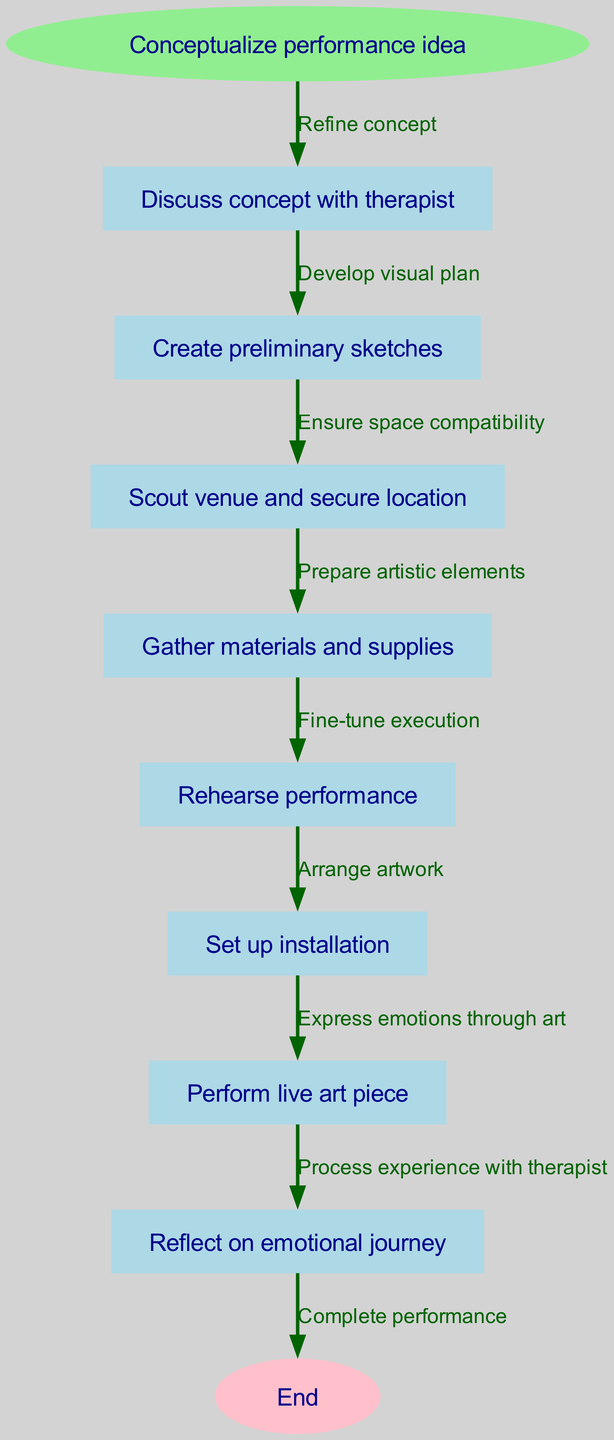What is the starting node of the diagram? The first node listed is "Conceptualize performance idea," which is explicitly marked as the start node in the diagram.
Answer: Conceptualize performance idea How many nodes are present in the diagram? By counting each unique step in the flow from start to end, there are a total of 8 nodes represented in the diagram, including the starting node and end node.
Answer: 8 What is the last step before the performance? The last step before the performance node is "Rehearse performance." This can be identified by following the path from the starting node through each subsequent step leading up to "Perform live art piece."
Answer: Rehearse performance What is the relationship between the "Scouting venue" and "Gather materials" nodes? The edge between "Scout venue and secure location" and "Gather materials and supplies" indicates that "Gather materials" follows immediately after "Scouting venue," signifying a sequential relationship in process preparation.
Answer: Sequential Which node directly follows the "Create preliminary sketches"? Following "Create preliminary sketches," the next node in the flow is "Scout venue and secure location," indicating the progression of steps after initial concept sketches.
Answer: Scout venue and secure location How does the emotional process relate to the preparation and performance? The flowchart shows that "Reflect on emotional journey" follows "Perform live art piece," indicating a reflection phase is integrated after the artistic execution, signifying emotional processing as crucial to the journey.
Answer: Reflect on emotional journey What step involves the physical arrangement of the artwork? The step that involves the physical arrangement of the artwork is "Set up installation." This node can be distinguished by examining the flowchart structure leading to where the artwork is prepared for the performance.
Answer: Set up installation What is the final node in the flowchart? The flowchart concludes with the node labeled "End," which signifies the completion of the live art performance process as defined in the diagram.
Answer: End 